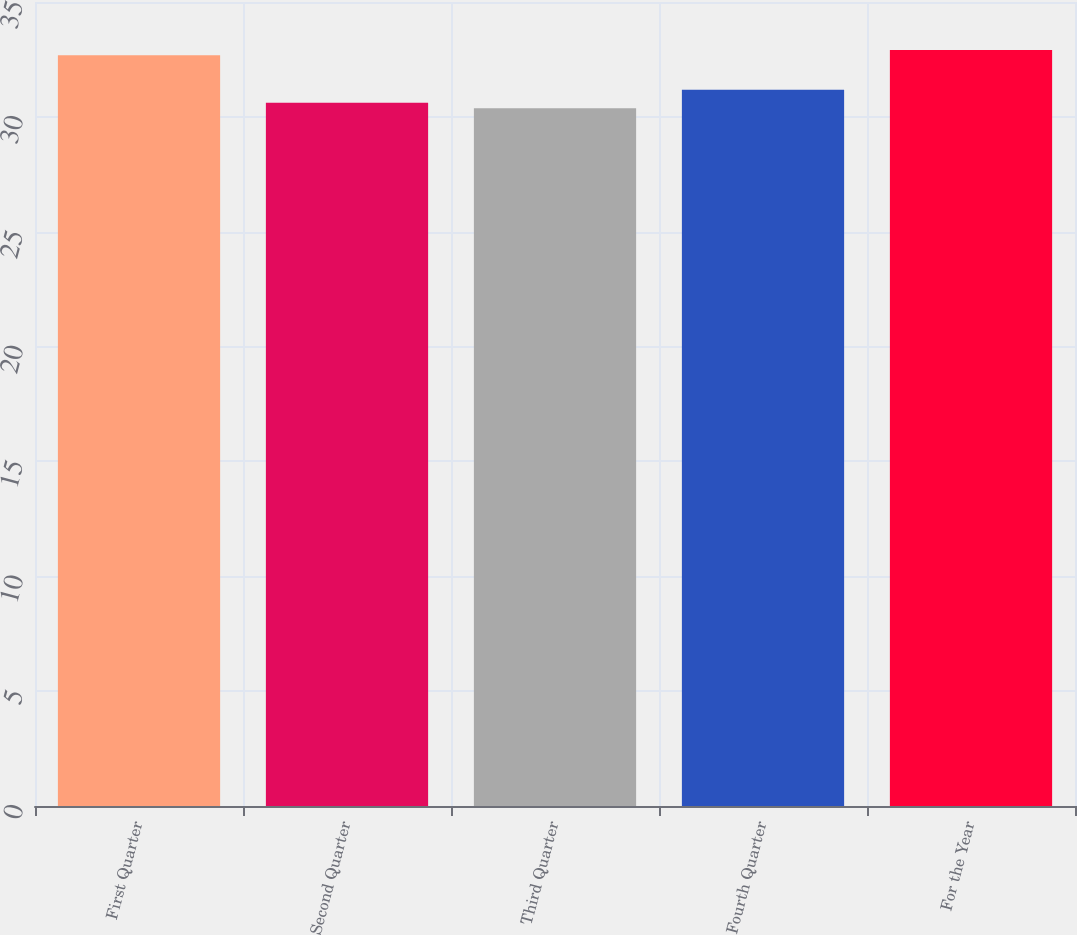<chart> <loc_0><loc_0><loc_500><loc_500><bar_chart><fcel>First Quarter<fcel>Second Quarter<fcel>Third Quarter<fcel>Fourth Quarter<fcel>For the Year<nl><fcel>32.68<fcel>30.61<fcel>30.38<fcel>31.18<fcel>32.91<nl></chart> 